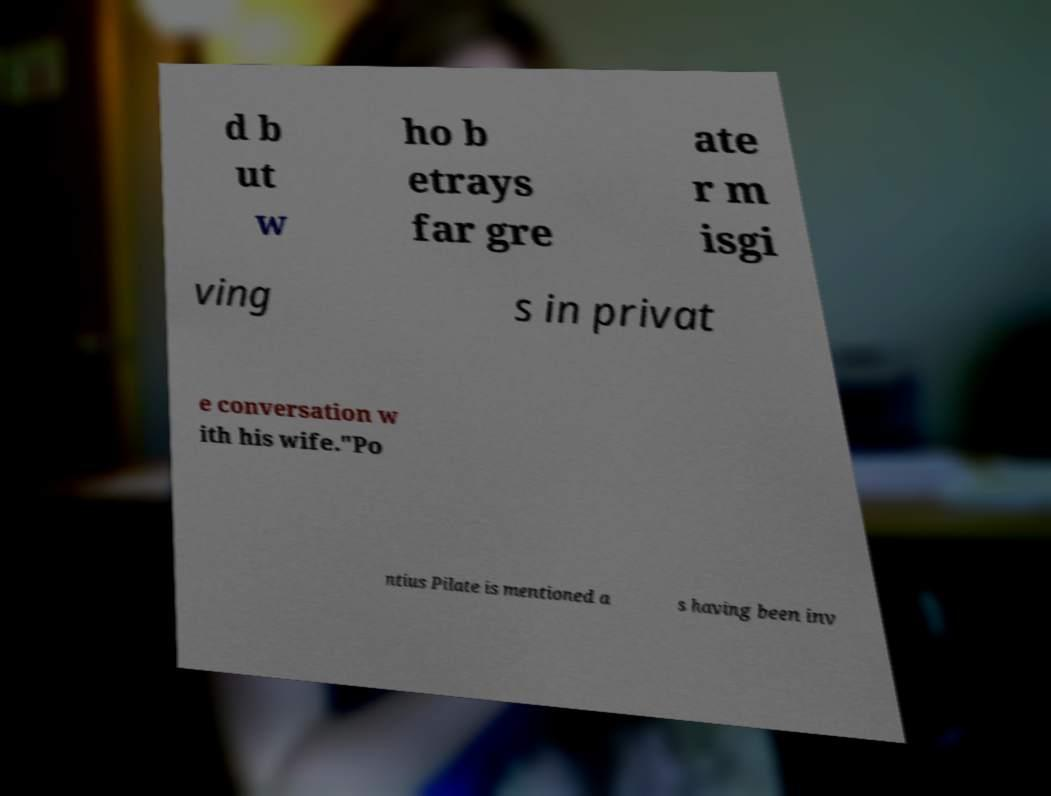Can you read and provide the text displayed in the image?This photo seems to have some interesting text. Can you extract and type it out for me? d b ut w ho b etrays far gre ate r m isgi ving s in privat e conversation w ith his wife."Po ntius Pilate is mentioned a s having been inv 